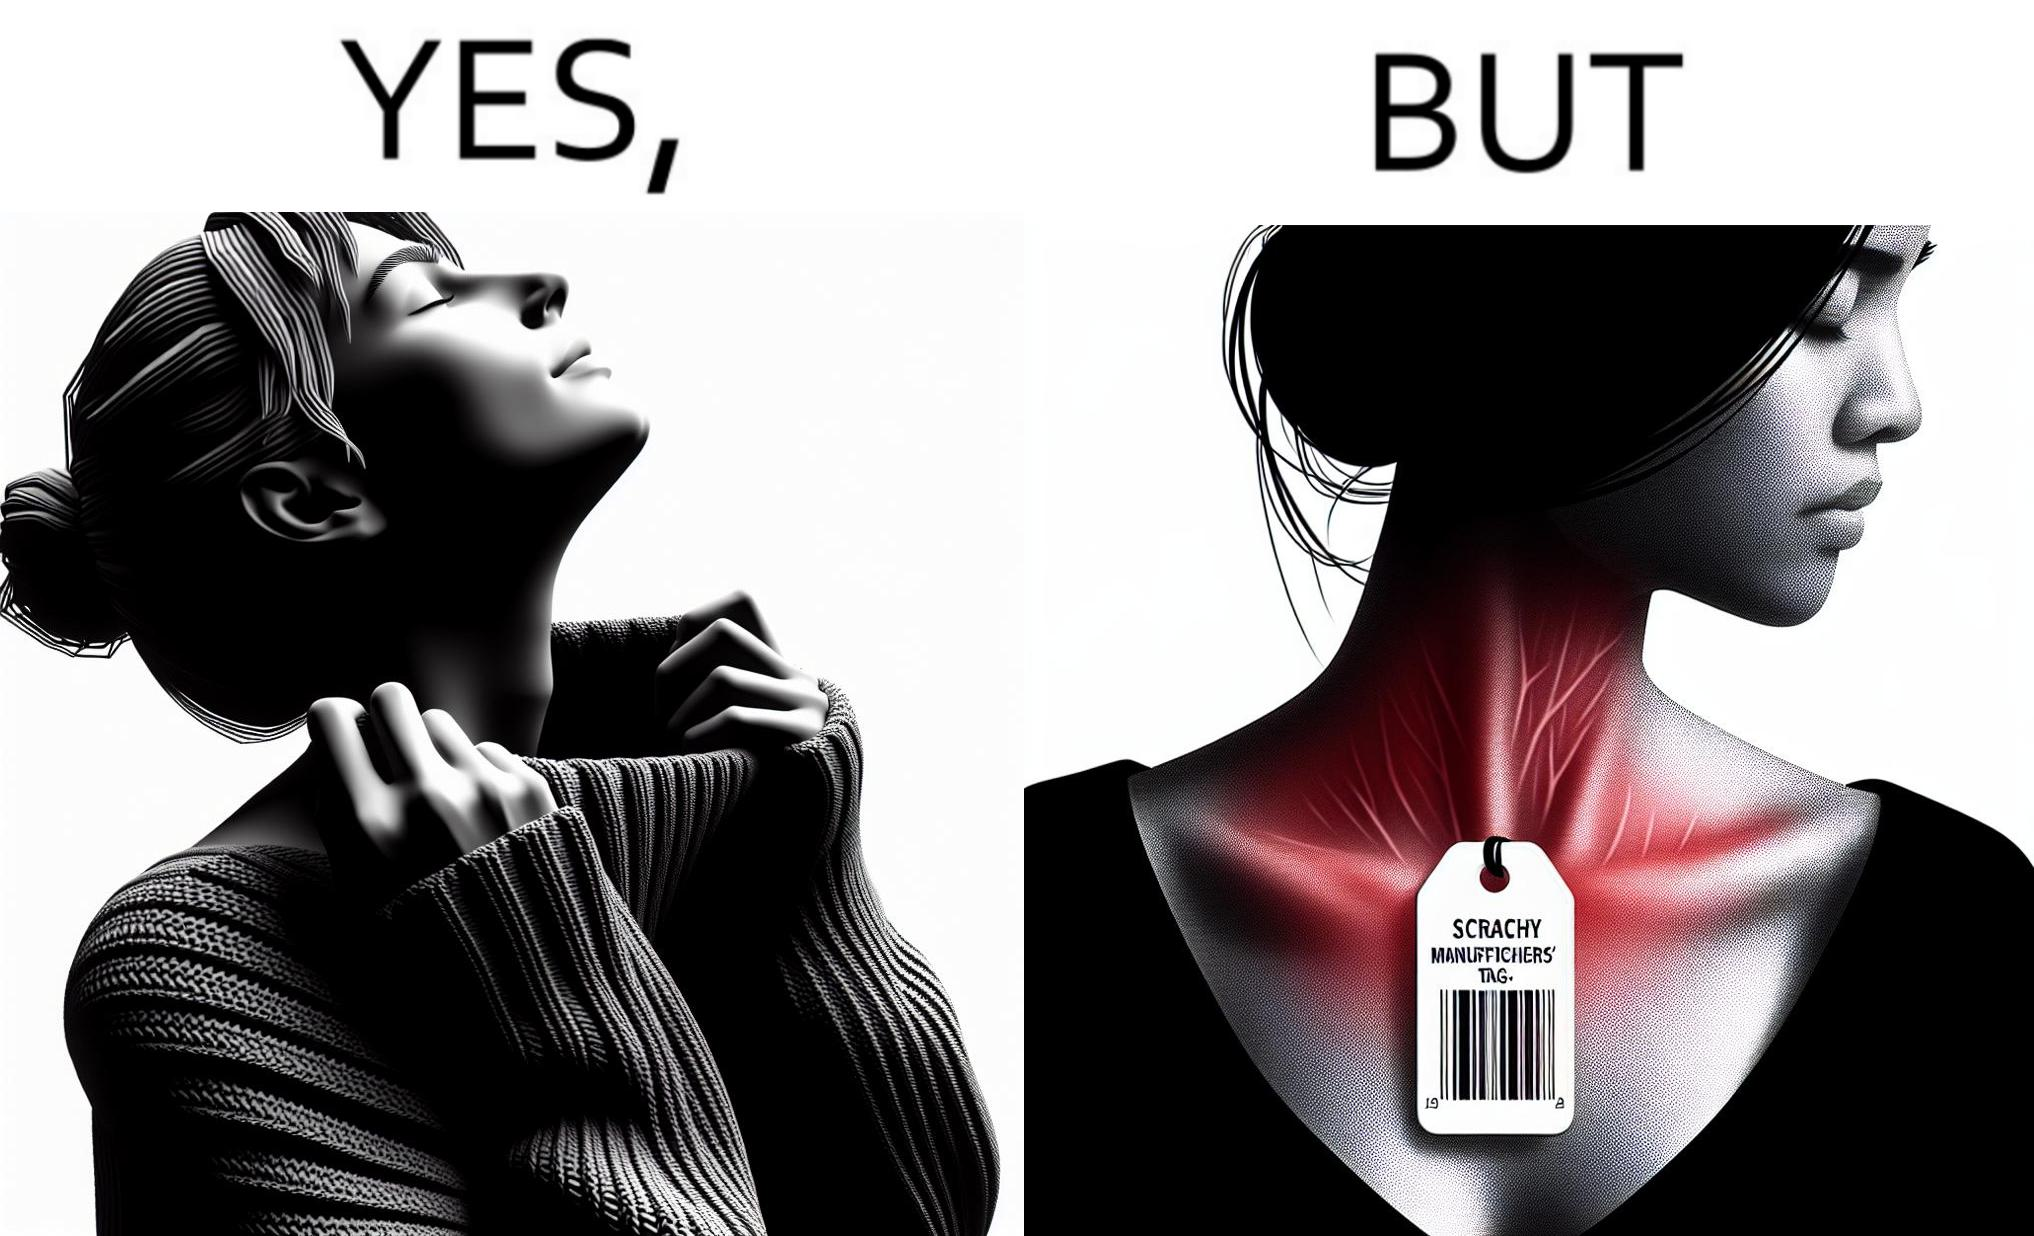Describe the contrast between the left and right parts of this image. In the left part of the image: It is a woman enjoying the warmth and comfort of her sweater In the right part of the image: It a womans neck, irritated and red due to manufacturers tags on her clothes 